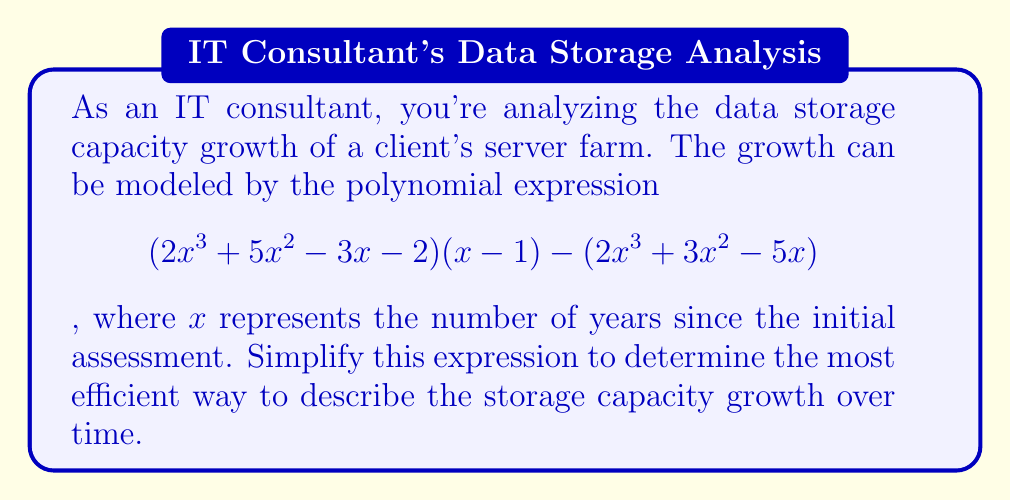Solve this math problem. Let's approach this step-by-step:

1) First, let's expand $(2x^3 + 5x^2 - 3x - 2)(x - 1)$:
   $$(2x^3 + 5x^2 - 3x - 2)(x - 1) = 2x^4 + 5x^3 - 3x^2 - 2x - 2x^3 - 5x^2 + 3x + 2$$
   $$= 2x^4 + 3x^3 - 8x^2 + x + 2$$

2) Now our expression looks like:
   $$(2x^4 + 3x^3 - 8x^2 + x + 2) - (2x^3 + 3x^2 - 5x)$$

3) Let's subtract the second polynomial from the first:
   $$2x^4 + 3x^3 - 8x^2 + x + 2$$
   $$- (2x^3 + 3x^2 - 5x)$$
   $$= 2x^4 + x^3 - 11x^2 + 6x + 2$$

4) This is our simplified polynomial. We can factor out the greatest common factor:
   $$2x^4 + x^3 - 11x^2 + 6x + 2 = 1(2x^4 + x^3 - 11x^2 + 6x + 2)$$

The polynomial cannot be factored further.
Answer: $$2x^4 + x^3 - 11x^2 + 6x + 2$$ 